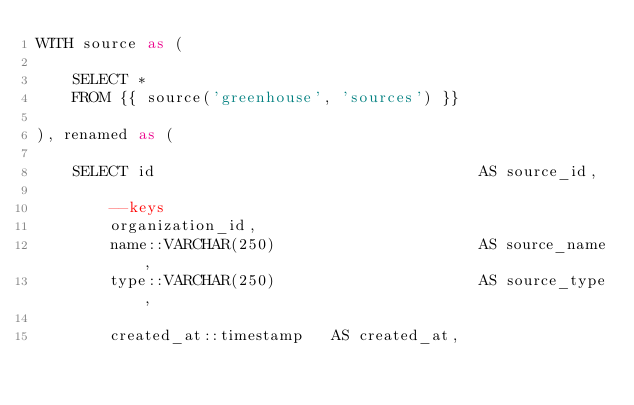<code> <loc_0><loc_0><loc_500><loc_500><_SQL_>WITH source as (

	SELECT *
  	FROM {{ source('greenhouse', 'sources') }}

), renamed as (

	SELECT id 									AS source_id,

		--keys
	    organization_id,
	    name::VARCHAR(250) 						AS source_name,
	    type::VARCHAR(250) 						AS source_type,

	    created_at::timestamp 	AS created_at,</code> 